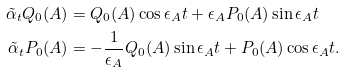<formula> <loc_0><loc_0><loc_500><loc_500>\tilde { \alpha } _ { t } Q _ { 0 } ( A ) & = Q _ { 0 } ( A ) \cos \epsilon _ { A } t + \epsilon _ { A } P _ { 0 } ( A ) \sin \epsilon _ { A } t \\ \tilde { \alpha } _ { t } P _ { 0 } ( A ) & = - \frac { 1 } { \epsilon _ { A } } Q _ { 0 } ( A ) \sin \epsilon _ { A } t + P _ { 0 } ( A ) \cos \epsilon _ { A } t .</formula> 